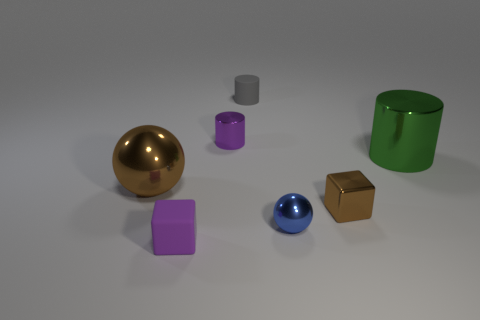There is a metallic cube that is the same color as the large ball; what size is it?
Offer a terse response. Small. Are there any other things of the same color as the small shiny cube?
Your response must be concise. Yes. What color is the matte cylinder on the right side of the ball to the left of the metallic cylinder to the left of the green metallic object?
Ensure brevity in your answer.  Gray. Does the metallic cube have the same color as the big shiny ball?
Make the answer very short. Yes. How many blue metal objects are the same size as the blue sphere?
Ensure brevity in your answer.  0. Are there more tiny objects that are behind the small shiny cylinder than green shiny cylinders left of the purple rubber thing?
Give a very brief answer. Yes. The small metal thing behind the big thing that is on the left side of the tiny brown metal cube is what color?
Your answer should be compact. Purple. Are the green cylinder and the blue ball made of the same material?
Offer a very short reply. Yes. Are there any small purple shiny objects of the same shape as the green shiny object?
Offer a terse response. Yes. There is a shiny object that is on the left side of the purple cylinder; is it the same color as the shiny block?
Make the answer very short. Yes. 